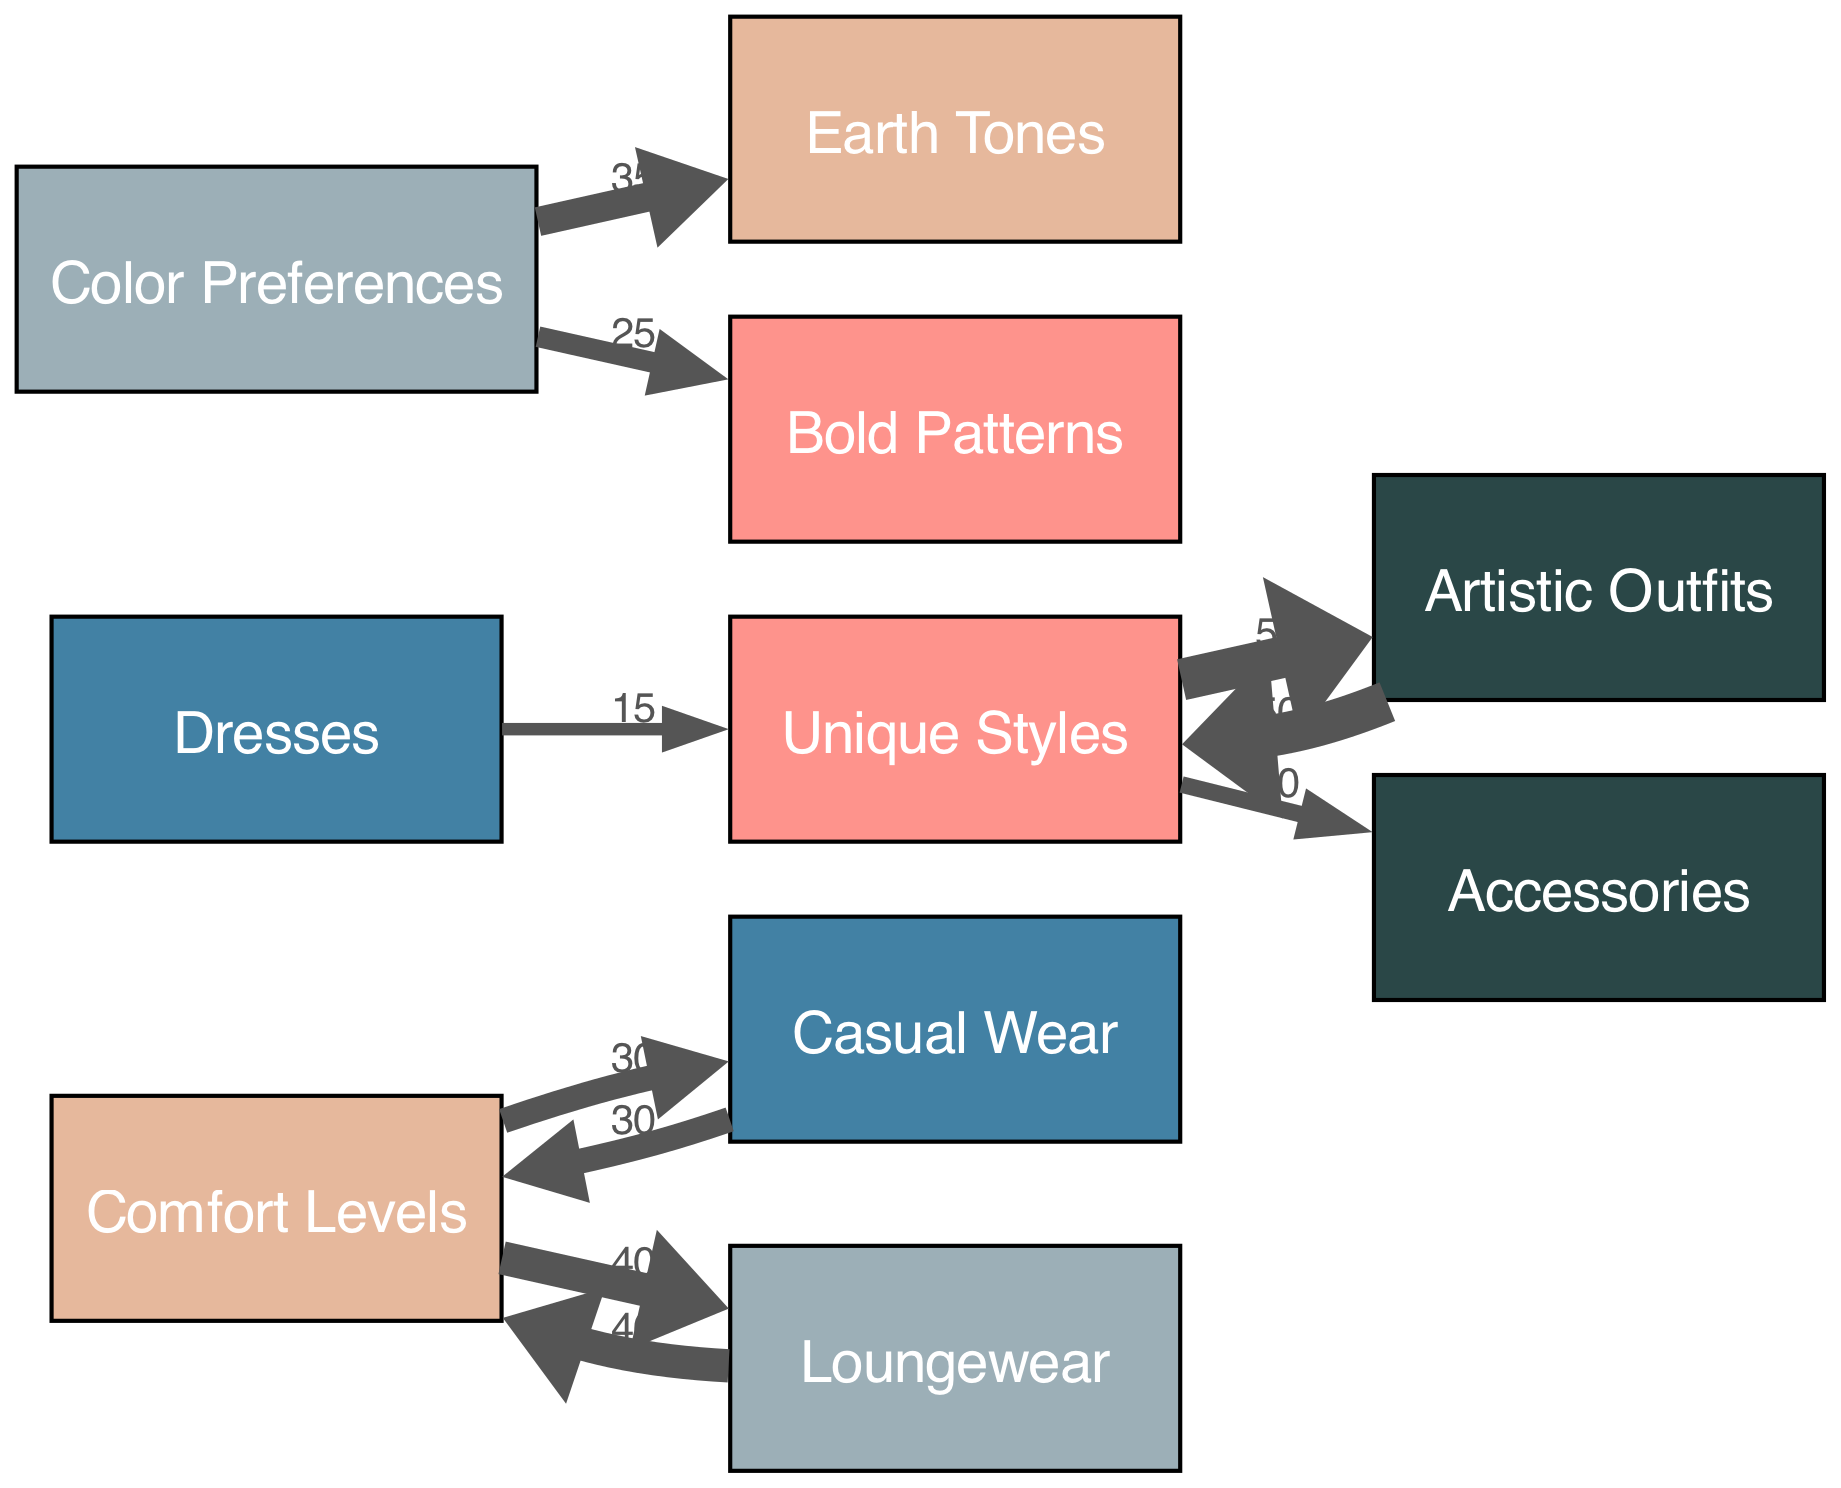What is the total number of nodes in the diagram? The diagram includes the main categories of Comfort Levels, Unique Styles, Color Preferences, and specific preferences like Casual Wear, Loungewear, Artistic Outfits, Dresses, Accessories, Earth Tones, and Bold Patterns. Counting these gives a total of 10 nodes.
Answer: 10 Which style has the highest comfort level value? The values for comfort levels show that Loungewear has a value of 40, while Casual Wear has a value of 30. Therefore, Loungewear has the highest comfort level value.
Answer: Loungewear What color preference is favored more, Earth Tones or Bold Patterns? The link from Color Preferences indicates that Earth Tones has a value of 35 and Bold Patterns has a value of 25. Since 35 is greater than 25, Earth Tones is favored more.
Answer: Earth Tones How many total units of comfort level are associated with Casual Wear? The diagram indicates that the comfort level value associated with Casual Wear is 30 directly, and it is also linked back to the Comfort Levels node (but that doesn't add more units). Hence, the total remains 30.
Answer: 30 What percentage of Unique Styles is attributed to Artistic Outfits? Artistic Outfits has a value of 50 linked to Unique Styles, while Dresses has a value of 15 in the same category. The total for Unique Styles is 50 + 15 = 65. The percentage is then calculated as (50/65) * 100 ≈ 76.92%.
Answer: Approximately 76.92% What is the total value of accessories in the unique styles category? Accessories has a value of 20 within the Unique Styles category. As it is the only linked value, the total value attributed to accessories in this context remains 20.
Answer: 20 Which outfit category has the lowest unique styles value? Among the links related to Unique Styles, Dresses only has a value of 15, compared to Artistic Outfits (50) and Accessories (20). Therefore, Dresses has the lowest unique styles value.
Answer: Dresses Is the relationship from Comfort Levels to Loungewear stronger or weaker than to Casual Wear? The value for the link from Comfort Levels to Loungewear is 40, while the value to Casual Wear is only 30. Since 40 is greater than 30, the relationship to Loungewear is stronger.
Answer: Stronger What is the total comfort level value represented in the diagram? The comfort levels show that Loungewear contributes 40 and Casual Wear contributes 30 directly. Adding these two values gives a total comfort level value of 40 + 30 = 70.
Answer: 70 